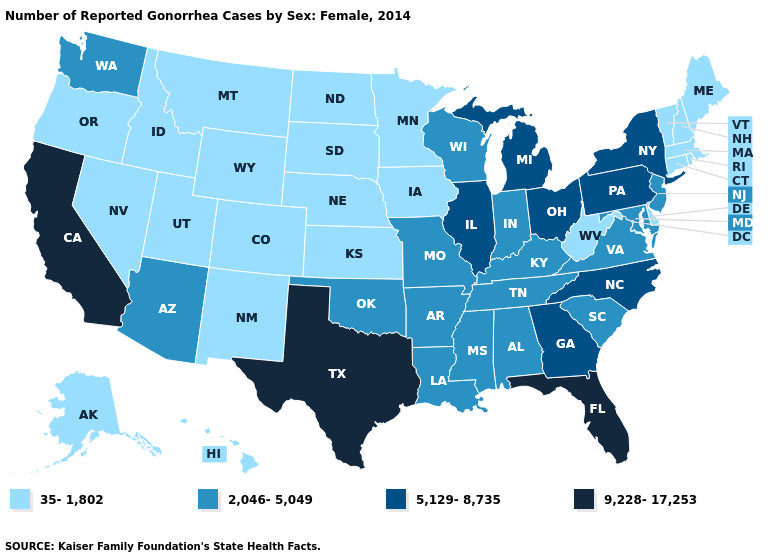Does Virginia have a lower value than Montana?
Answer briefly. No. Does Iowa have a lower value than Nevada?
Be succinct. No. Does the first symbol in the legend represent the smallest category?
Be succinct. Yes. Does Missouri have the same value as Mississippi?
Be succinct. Yes. Name the states that have a value in the range 35-1,802?
Concise answer only. Alaska, Colorado, Connecticut, Delaware, Hawaii, Idaho, Iowa, Kansas, Maine, Massachusetts, Minnesota, Montana, Nebraska, Nevada, New Hampshire, New Mexico, North Dakota, Oregon, Rhode Island, South Dakota, Utah, Vermont, West Virginia, Wyoming. What is the lowest value in the West?
Answer briefly. 35-1,802. Does Nebraska have the lowest value in the MidWest?
Give a very brief answer. Yes. Name the states that have a value in the range 2,046-5,049?
Concise answer only. Alabama, Arizona, Arkansas, Indiana, Kentucky, Louisiana, Maryland, Mississippi, Missouri, New Jersey, Oklahoma, South Carolina, Tennessee, Virginia, Washington, Wisconsin. Which states have the lowest value in the South?
Keep it brief. Delaware, West Virginia. How many symbols are there in the legend?
Be succinct. 4. How many symbols are there in the legend?
Short answer required. 4. Is the legend a continuous bar?
Concise answer only. No. What is the highest value in states that border Wisconsin?
Be succinct. 5,129-8,735. Does the first symbol in the legend represent the smallest category?
Keep it brief. Yes. 